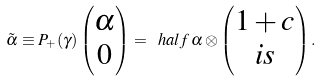Convert formula to latex. <formula><loc_0><loc_0><loc_500><loc_500>\tilde { \alpha } \equiv P _ { + } ( \gamma ) \begin{pmatrix} \alpha \\ 0 \end{pmatrix} = \ h a l f \, \alpha \otimes \begin{pmatrix} 1 + c \\ i s \end{pmatrix} .</formula> 